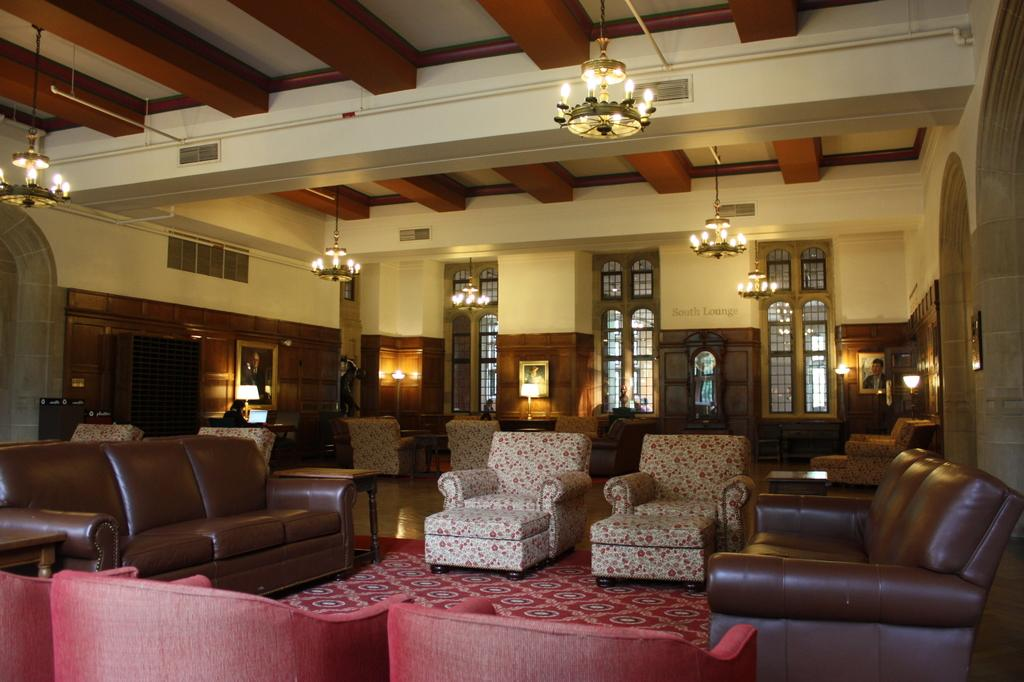What type of space is depicted in the image? There is a room in the image. What furniture is present in the room? There is a sofa and a chair in the room. What can be seen in the background of the room? There is a wall, a pillar, lights, and a cupboard in the background of the room. Can you tell me how many queens are playing spades in the room? There is no reference to any queens or card games in the image; it features a room with furniture and background elements. 